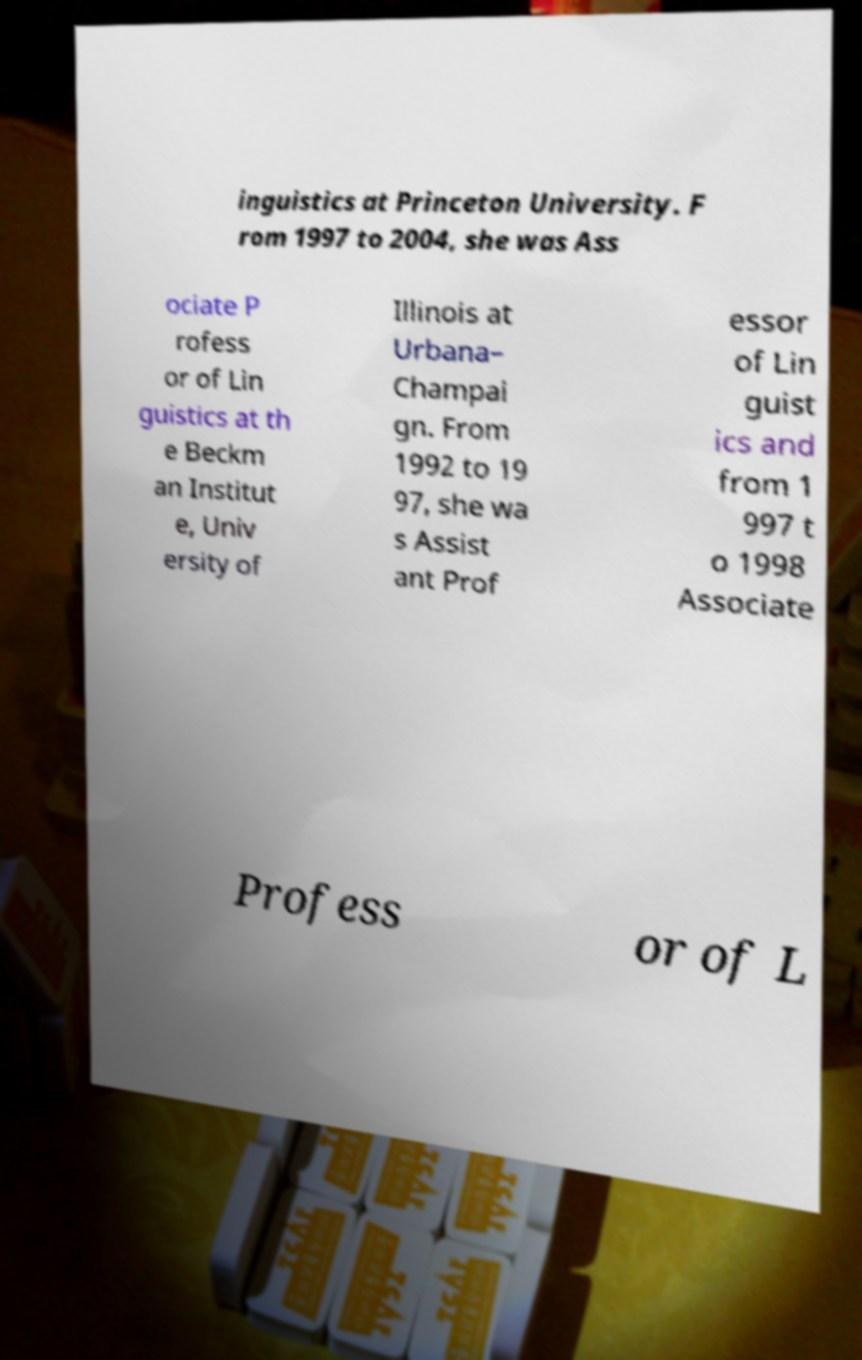What messages or text are displayed in this image? I need them in a readable, typed format. inguistics at Princeton University. F rom 1997 to 2004, she was Ass ociate P rofess or of Lin guistics at th e Beckm an Institut e, Univ ersity of Illinois at Urbana– Champai gn. From 1992 to 19 97, she wa s Assist ant Prof essor of Lin guist ics and from 1 997 t o 1998 Associate Profess or of L 